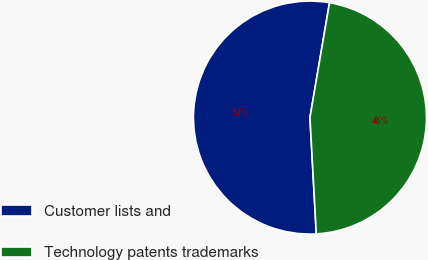Convert chart. <chart><loc_0><loc_0><loc_500><loc_500><pie_chart><fcel>Customer lists and<fcel>Technology patents trademarks<nl><fcel>53.55%<fcel>46.45%<nl></chart> 